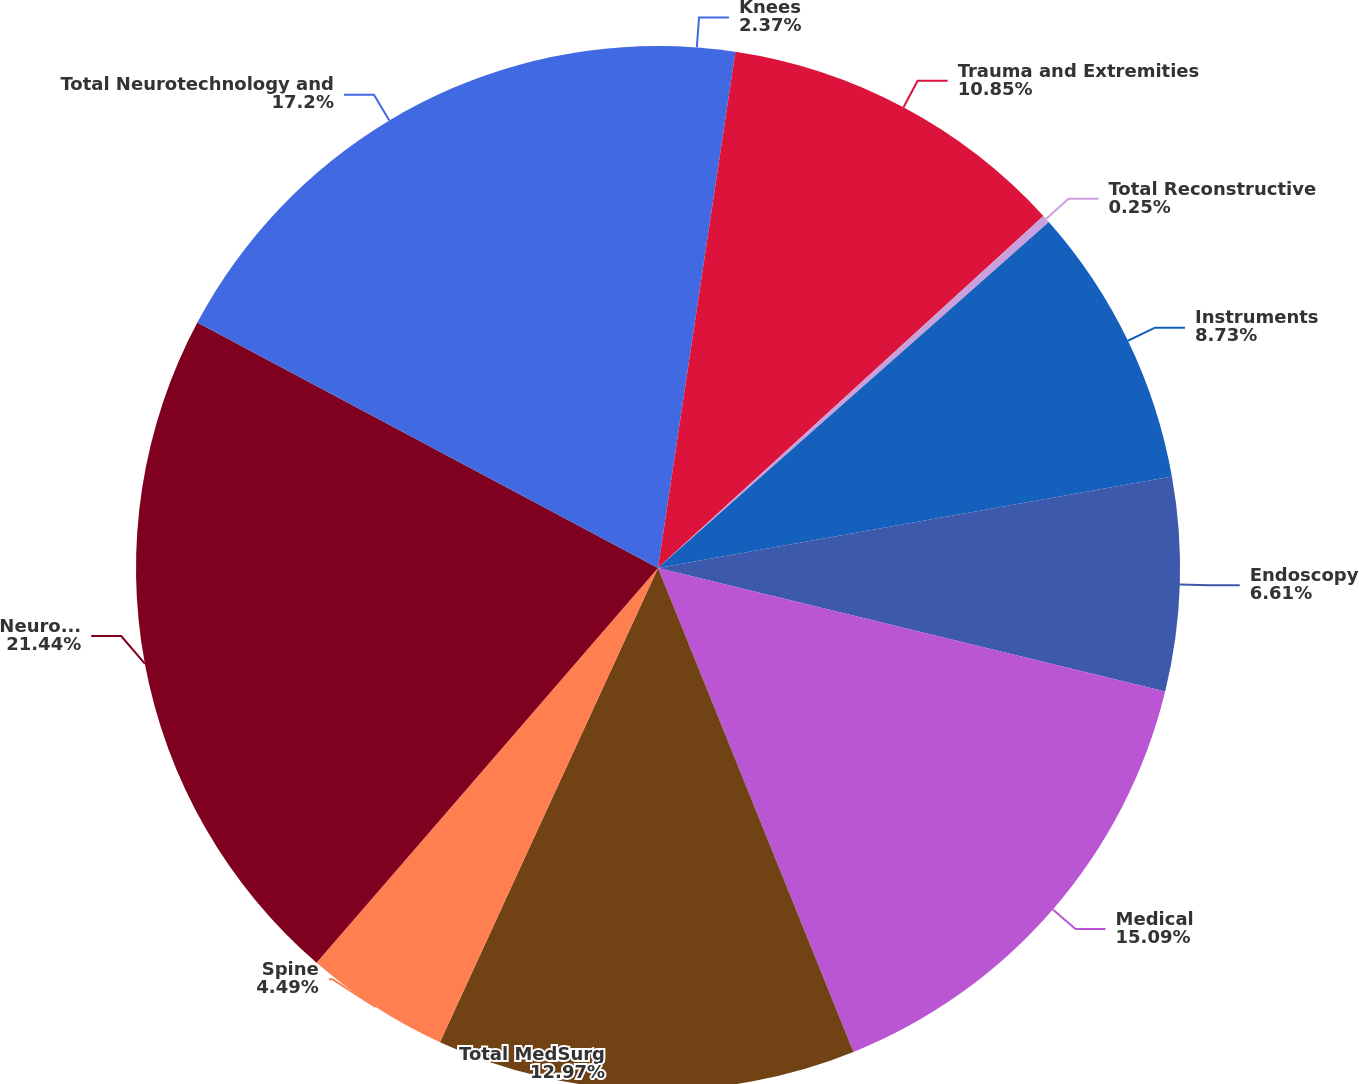Convert chart. <chart><loc_0><loc_0><loc_500><loc_500><pie_chart><fcel>Knees<fcel>Trauma and Extremities<fcel>Total Reconstructive<fcel>Instruments<fcel>Endoscopy<fcel>Medical<fcel>Total MedSurg<fcel>Spine<fcel>Neurotechnology<fcel>Total Neurotechnology and<nl><fcel>2.37%<fcel>10.85%<fcel>0.25%<fcel>8.73%<fcel>6.61%<fcel>15.09%<fcel>12.97%<fcel>4.49%<fcel>21.45%<fcel>17.21%<nl></chart> 